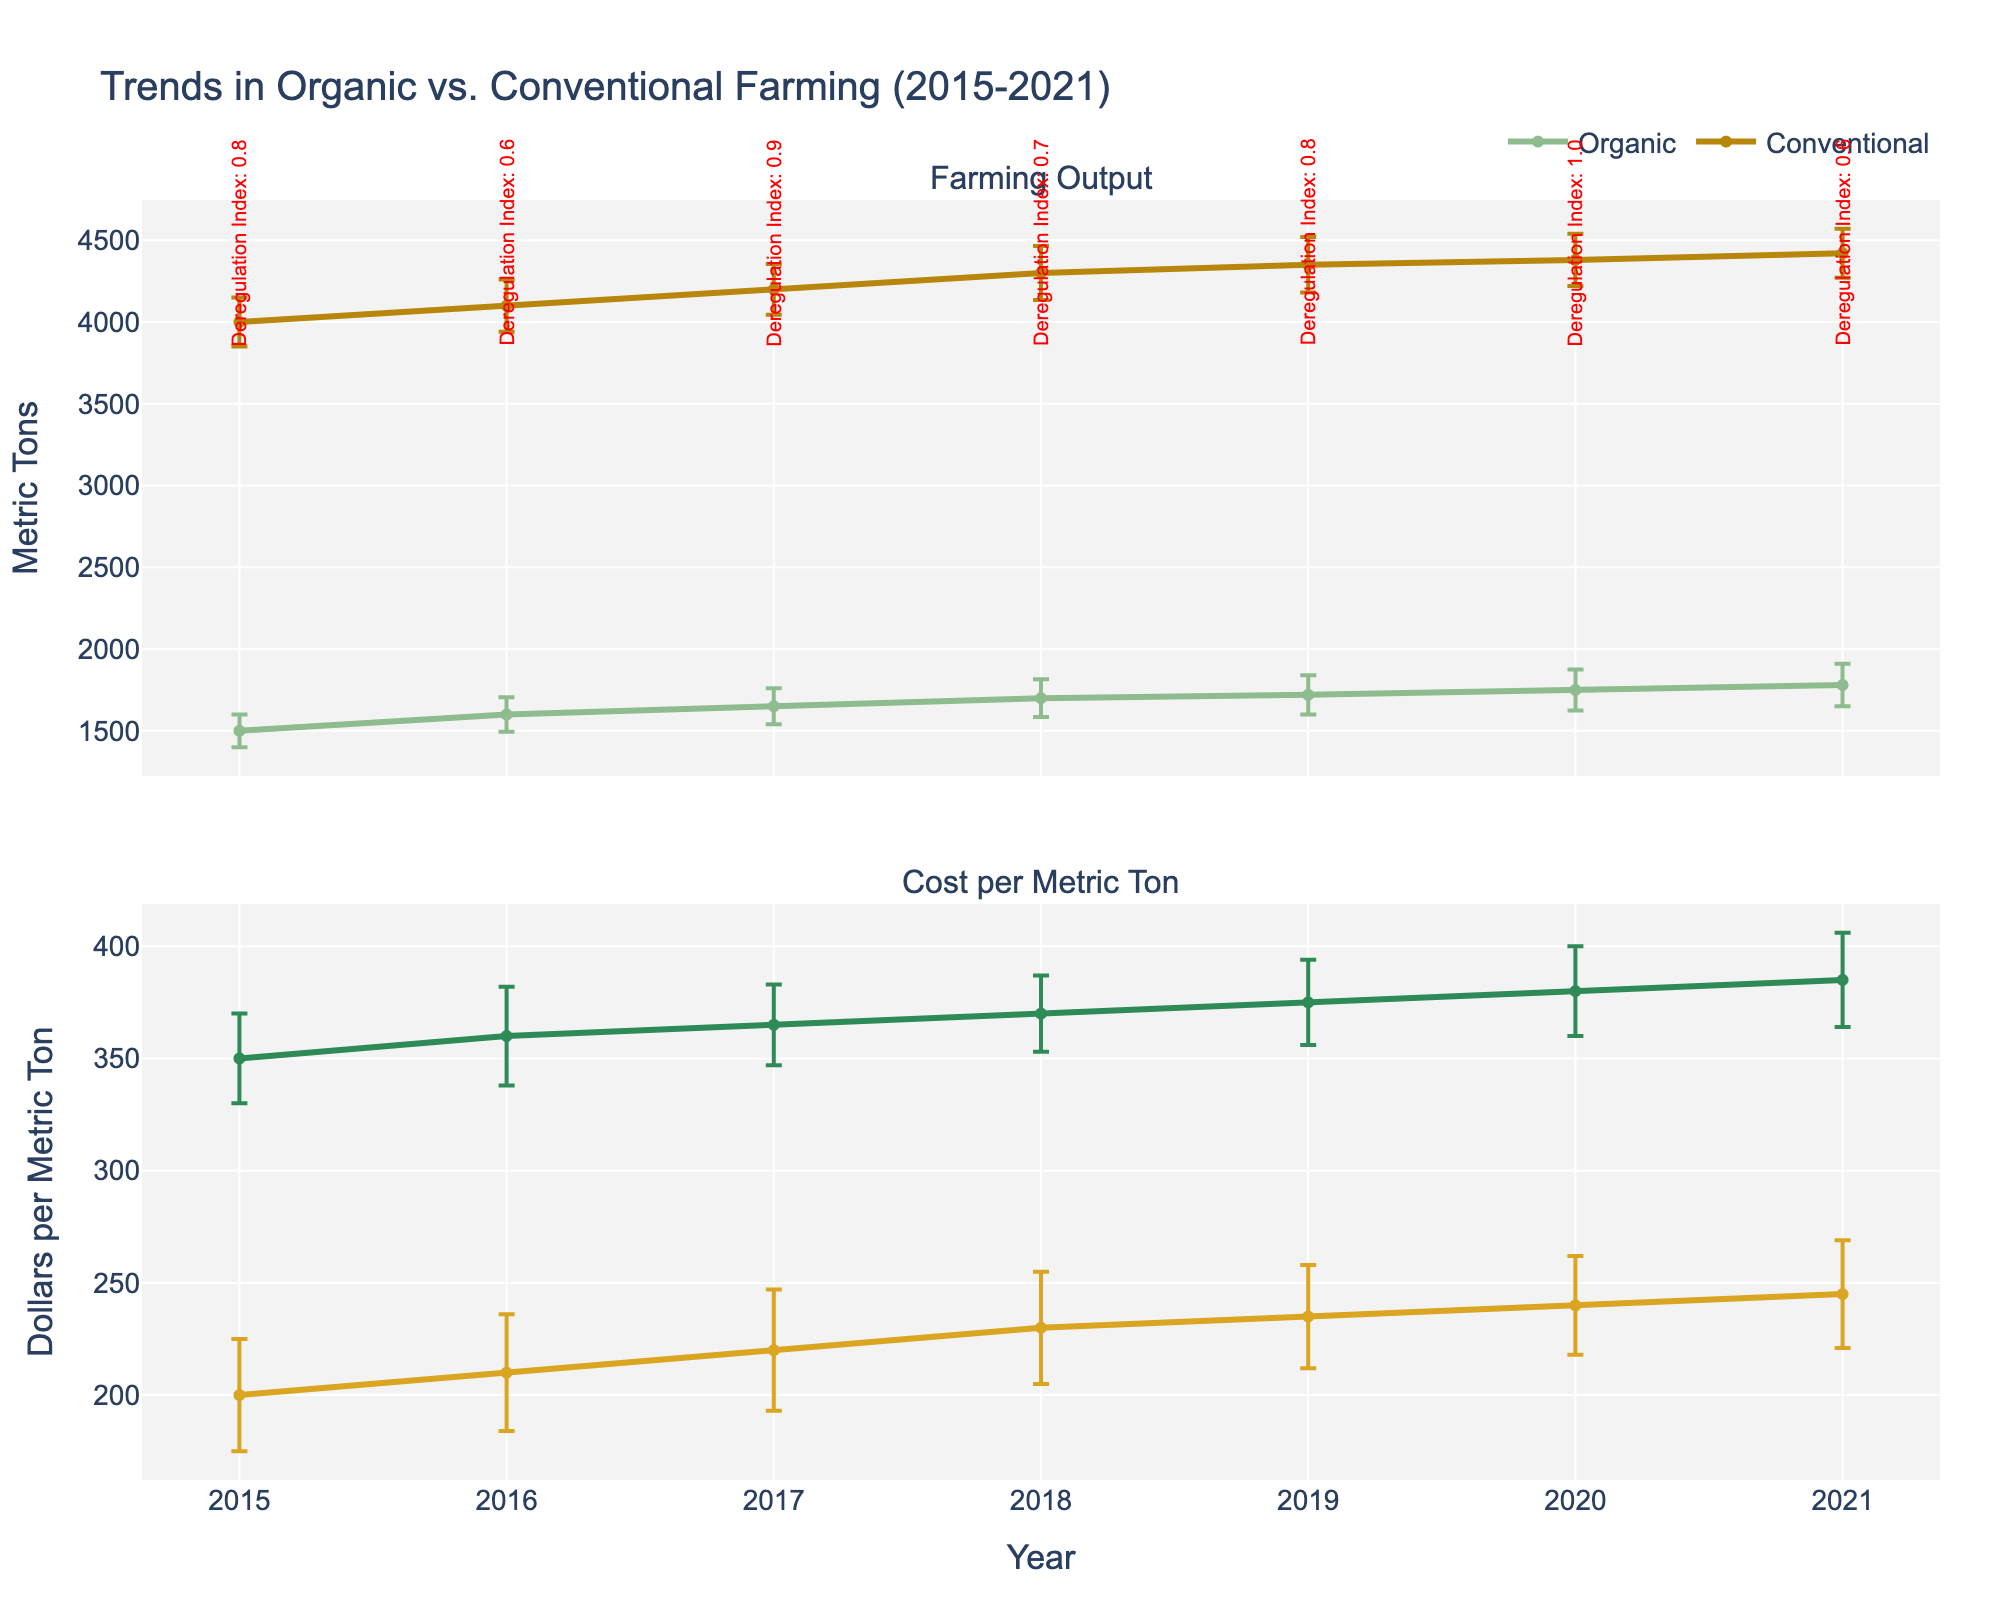what's the title of the plot? The title of the plot is shown at the top and is used to give an overview of what the figure represents. In this case, it reads "Trends in Organic vs. Conventional Farming (2015-2021)."
Answer: Trends in Organic vs. Conventional Farming (2015-2021) how many types of farming are shown in the plot? The plot has two types of farming, represented by different lines. One line is for Organic farming, and the other is for Conventional farming.
Answer: Two which type of farming had a lower cost in 2017? By looking at the second subplot for 2017, the line representing the conventional farming cost is lower than the line representing the organic farming cost.
Answer: Conventional in which year did the organic farming output reach the highest value? From the first subplot, the peak of the organic farming output line is in 2021, where it reaches a metric tons value of 1780.
Answer: 2021 how much did the cost of Organic farming increase from 2015 to 2021? In 2015, the cost of Organic farming was $350 per metric ton. By 2021, it increased to $385 per metric ton. The difference is $385 - $350 = $35.
Answer: $35 which year had the greatest difference between conventional and organic farming outputs? The first subplot shows that the greatest difference between conventional and organic farming outputs occurs in 2015, where the conventional output is 4000 metric tons and organic output is 1500 metric tons. The difference is 4000 - 1500 = 2500 metric tons.
Answer: 2015 in what year was the deregulation index for organic farming the highest and what was its value? The annotations above each year indicate that in 2020, the Deregulation Index for organic farming was highest with a value of 1.0.
Answer: 2020 with 1.0 what was the error margin for the cost of conventional farming in 2016? The error bars for the conventional farming cost in the second subplot show that the error margin in 2016 extends ±26 dollars from the central value.
Answer: ±26 dollars compare the general trend of organic farming output to its cost between 2015 and 2021 The trend shows that while the organic farming output has consistently increased from 1500 to 1780 metric tons, the cost has also risen steadily from $350 to $385 per metric ton.
Answer: Both rising what does the color blue typically represent in these types of plots? In these types of plots, blue is often used to represent conventional farming, as it is a common color choice for such standard or baseline comparisons.
Answer: Conventional 